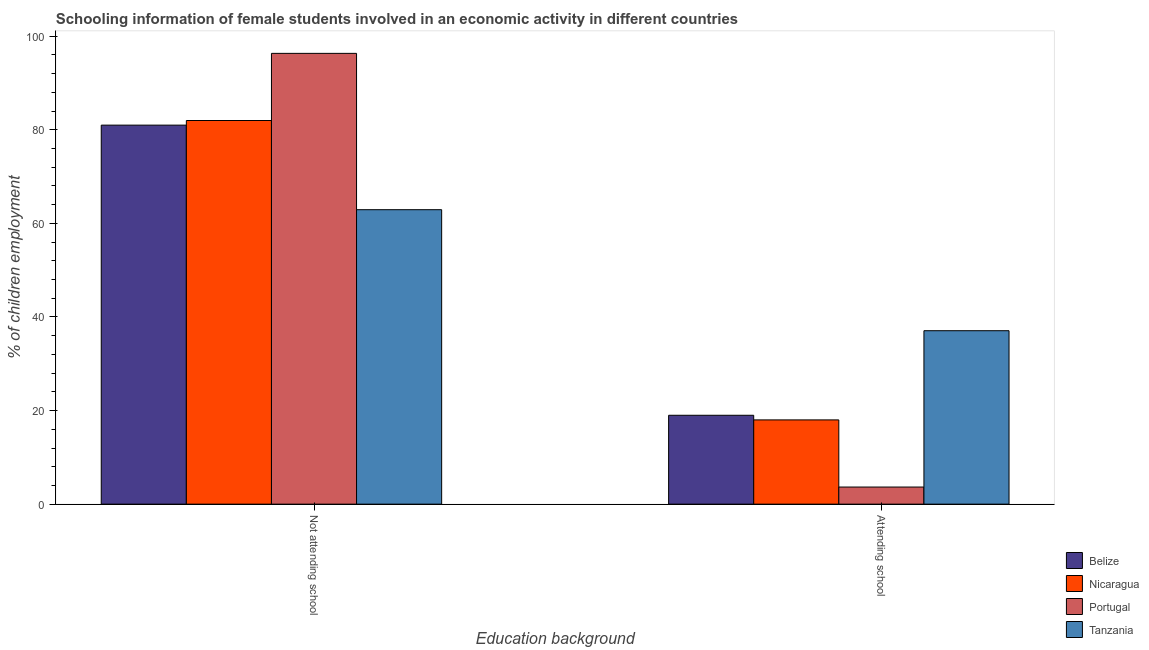How many bars are there on the 2nd tick from the right?
Offer a terse response. 4. What is the label of the 2nd group of bars from the left?
Provide a succinct answer. Attending school. What is the percentage of employed females who are attending school in Nicaragua?
Offer a terse response. 18.01. Across all countries, what is the maximum percentage of employed females who are not attending school?
Give a very brief answer. 96.34. Across all countries, what is the minimum percentage of employed females who are attending school?
Your response must be concise. 3.66. In which country was the percentage of employed females who are attending school maximum?
Your response must be concise. Tanzania. In which country was the percentage of employed females who are attending school minimum?
Give a very brief answer. Portugal. What is the total percentage of employed females who are not attending school in the graph?
Ensure brevity in your answer.  322.27. What is the difference between the percentage of employed females who are attending school in Portugal and that in Belize?
Your answer should be very brief. -15.34. What is the difference between the percentage of employed females who are not attending school in Portugal and the percentage of employed females who are attending school in Tanzania?
Offer a terse response. 59.28. What is the average percentage of employed females who are attending school per country?
Offer a very short reply. 19.43. What is the difference between the percentage of employed females who are attending school and percentage of employed females who are not attending school in Tanzania?
Give a very brief answer. -25.87. What is the ratio of the percentage of employed females who are attending school in Nicaragua to that in Belize?
Provide a short and direct response. 0.95. Is the percentage of employed females who are attending school in Belize less than that in Tanzania?
Your answer should be very brief. Yes. In how many countries, is the percentage of employed females who are attending school greater than the average percentage of employed females who are attending school taken over all countries?
Offer a very short reply. 1. What does the 2nd bar from the left in Attending school represents?
Give a very brief answer. Nicaragua. What does the 2nd bar from the right in Not attending school represents?
Offer a terse response. Portugal. How many bars are there?
Keep it short and to the point. 8. Does the graph contain any zero values?
Ensure brevity in your answer.  No. Does the graph contain grids?
Offer a very short reply. No. Where does the legend appear in the graph?
Provide a short and direct response. Bottom right. How are the legend labels stacked?
Ensure brevity in your answer.  Vertical. What is the title of the graph?
Offer a very short reply. Schooling information of female students involved in an economic activity in different countries. What is the label or title of the X-axis?
Offer a terse response. Education background. What is the label or title of the Y-axis?
Keep it short and to the point. % of children employment. What is the % of children employment in Belize in Not attending school?
Provide a short and direct response. 81. What is the % of children employment in Nicaragua in Not attending school?
Ensure brevity in your answer.  81.99. What is the % of children employment of Portugal in Not attending school?
Offer a terse response. 96.34. What is the % of children employment in Tanzania in Not attending school?
Your answer should be compact. 62.93. What is the % of children employment in Belize in Attending school?
Make the answer very short. 19. What is the % of children employment of Nicaragua in Attending school?
Your answer should be very brief. 18.01. What is the % of children employment of Portugal in Attending school?
Keep it short and to the point. 3.66. What is the % of children employment in Tanzania in Attending school?
Your answer should be very brief. 37.07. Across all Education background, what is the maximum % of children employment in Belize?
Keep it short and to the point. 81. Across all Education background, what is the maximum % of children employment in Nicaragua?
Your response must be concise. 81.99. Across all Education background, what is the maximum % of children employment of Portugal?
Make the answer very short. 96.34. Across all Education background, what is the maximum % of children employment in Tanzania?
Offer a terse response. 62.93. Across all Education background, what is the minimum % of children employment of Belize?
Offer a terse response. 19. Across all Education background, what is the minimum % of children employment in Nicaragua?
Your answer should be very brief. 18.01. Across all Education background, what is the minimum % of children employment of Portugal?
Offer a terse response. 3.66. Across all Education background, what is the minimum % of children employment of Tanzania?
Your answer should be very brief. 37.07. What is the total % of children employment of Belize in the graph?
Your response must be concise. 100. What is the total % of children employment in Portugal in the graph?
Your answer should be very brief. 100. What is the total % of children employment of Tanzania in the graph?
Your answer should be compact. 100. What is the difference between the % of children employment of Belize in Not attending school and that in Attending school?
Your response must be concise. 62.01. What is the difference between the % of children employment of Nicaragua in Not attending school and that in Attending school?
Your response must be concise. 63.99. What is the difference between the % of children employment in Portugal in Not attending school and that in Attending school?
Give a very brief answer. 92.69. What is the difference between the % of children employment in Tanzania in Not attending school and that in Attending school?
Ensure brevity in your answer.  25.87. What is the difference between the % of children employment of Belize in Not attending school and the % of children employment of Nicaragua in Attending school?
Provide a succinct answer. 63. What is the difference between the % of children employment of Belize in Not attending school and the % of children employment of Portugal in Attending school?
Your answer should be very brief. 77.35. What is the difference between the % of children employment in Belize in Not attending school and the % of children employment in Tanzania in Attending school?
Your response must be concise. 43.94. What is the difference between the % of children employment of Nicaragua in Not attending school and the % of children employment of Portugal in Attending school?
Your answer should be very brief. 78.34. What is the difference between the % of children employment in Nicaragua in Not attending school and the % of children employment in Tanzania in Attending school?
Provide a short and direct response. 44.93. What is the difference between the % of children employment in Portugal in Not attending school and the % of children employment in Tanzania in Attending school?
Your answer should be very brief. 59.28. What is the average % of children employment of Belize per Education background?
Offer a very short reply. 50. What is the average % of children employment of Nicaragua per Education background?
Your response must be concise. 50. What is the average % of children employment in Portugal per Education background?
Your response must be concise. 50. What is the average % of children employment in Tanzania per Education background?
Offer a terse response. 50. What is the difference between the % of children employment in Belize and % of children employment in Nicaragua in Not attending school?
Keep it short and to the point. -0.99. What is the difference between the % of children employment in Belize and % of children employment in Portugal in Not attending school?
Offer a terse response. -15.34. What is the difference between the % of children employment in Belize and % of children employment in Tanzania in Not attending school?
Offer a very short reply. 18.07. What is the difference between the % of children employment of Nicaragua and % of children employment of Portugal in Not attending school?
Your answer should be compact. -14.35. What is the difference between the % of children employment of Nicaragua and % of children employment of Tanzania in Not attending school?
Your answer should be very brief. 19.06. What is the difference between the % of children employment of Portugal and % of children employment of Tanzania in Not attending school?
Ensure brevity in your answer.  33.41. What is the difference between the % of children employment in Belize and % of children employment in Nicaragua in Attending school?
Provide a succinct answer. 0.99. What is the difference between the % of children employment of Belize and % of children employment of Portugal in Attending school?
Provide a succinct answer. 15.34. What is the difference between the % of children employment in Belize and % of children employment in Tanzania in Attending school?
Your answer should be very brief. -18.07. What is the difference between the % of children employment in Nicaragua and % of children employment in Portugal in Attending school?
Offer a very short reply. 14.35. What is the difference between the % of children employment in Nicaragua and % of children employment in Tanzania in Attending school?
Make the answer very short. -19.06. What is the difference between the % of children employment in Portugal and % of children employment in Tanzania in Attending school?
Your answer should be very brief. -33.41. What is the ratio of the % of children employment in Belize in Not attending school to that in Attending school?
Your answer should be compact. 4.26. What is the ratio of the % of children employment in Nicaragua in Not attending school to that in Attending school?
Your answer should be compact. 4.55. What is the ratio of the % of children employment in Portugal in Not attending school to that in Attending school?
Make the answer very short. 26.34. What is the ratio of the % of children employment in Tanzania in Not attending school to that in Attending school?
Offer a terse response. 1.7. What is the difference between the highest and the second highest % of children employment of Belize?
Provide a succinct answer. 62.01. What is the difference between the highest and the second highest % of children employment in Nicaragua?
Offer a very short reply. 63.99. What is the difference between the highest and the second highest % of children employment in Portugal?
Provide a short and direct response. 92.69. What is the difference between the highest and the second highest % of children employment of Tanzania?
Give a very brief answer. 25.87. What is the difference between the highest and the lowest % of children employment in Belize?
Ensure brevity in your answer.  62.01. What is the difference between the highest and the lowest % of children employment in Nicaragua?
Your answer should be compact. 63.99. What is the difference between the highest and the lowest % of children employment in Portugal?
Provide a short and direct response. 92.69. What is the difference between the highest and the lowest % of children employment in Tanzania?
Provide a short and direct response. 25.87. 